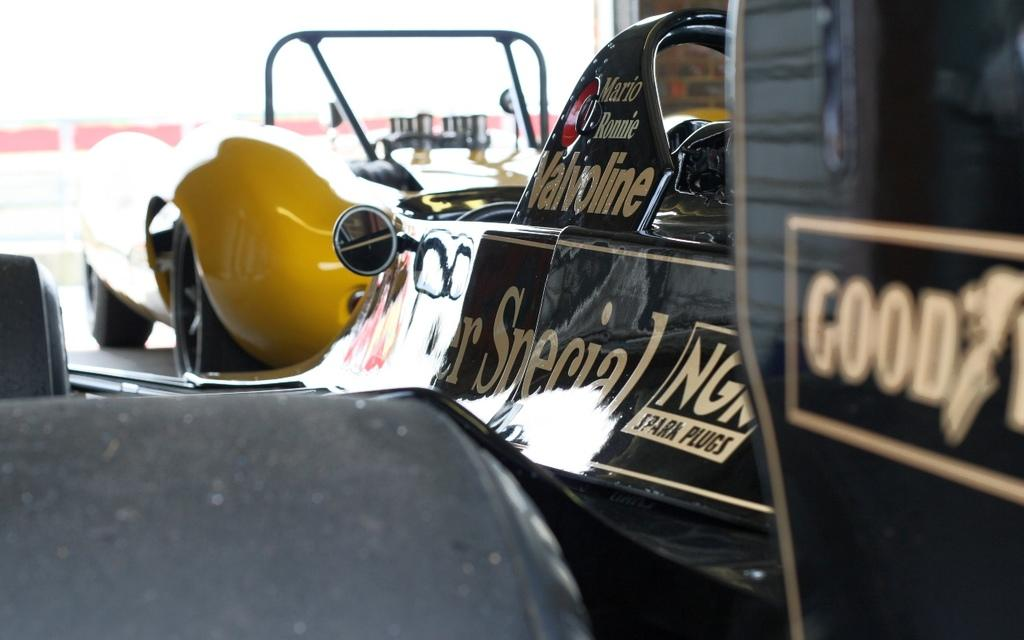What is the main subject in the image? There is a vehicle in the image. What else can be seen in the image besides the vehicle? There are boards in the image. What is written on the boards? Something is written on the boards. Can you describe the objects in the image? There are objects in the image. How many women are visible in the image? There is no mention of women in the provided facts, so we cannot determine the number of women in the image. 